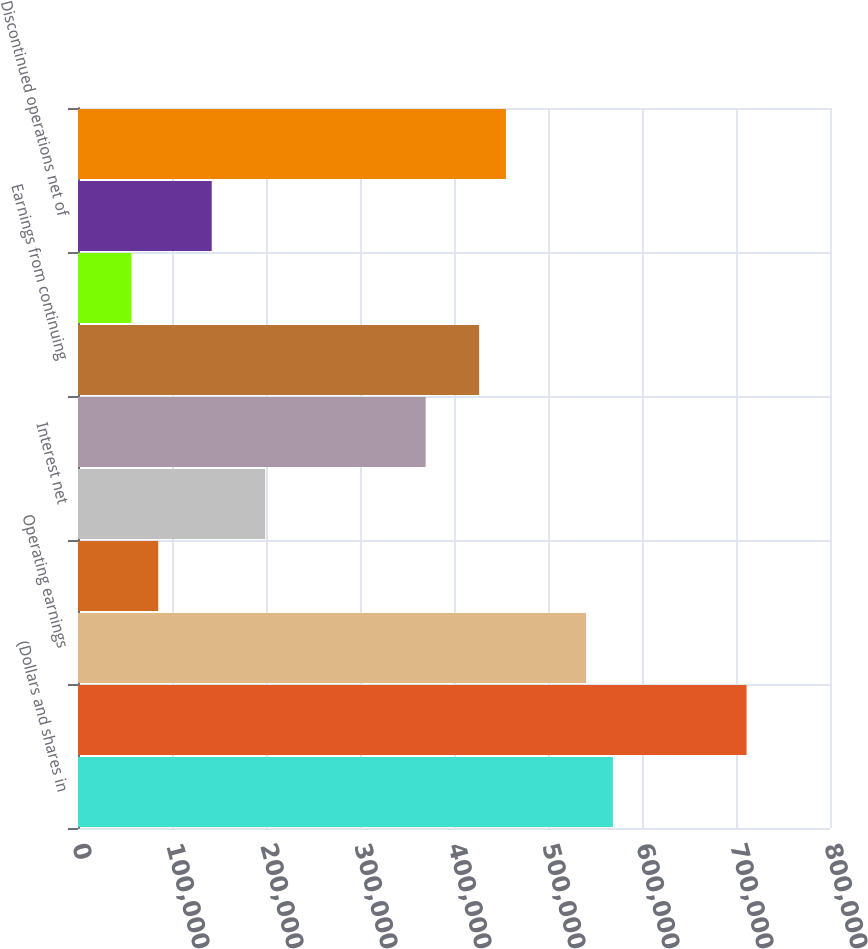Convert chart to OTSL. <chart><loc_0><loc_0><loc_500><loc_500><bar_chart><fcel>(Dollars and shares in<fcel>Net sales<fcel>Operating earnings<fcel>Operating margin<fcel>Interest net<fcel>Provision for income taxes net<fcel>Earnings from continuing<fcel>Return on sales (a)<fcel>Discontinued operations net of<fcel>Net earnings<nl><fcel>568999<fcel>711249<fcel>540549<fcel>85350.5<fcel>199150<fcel>369850<fcel>426750<fcel>56900.6<fcel>142250<fcel>455200<nl></chart> 